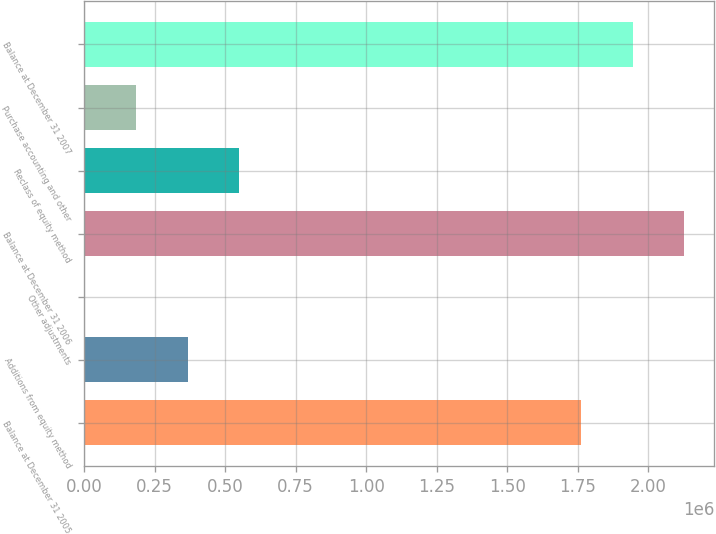Convert chart to OTSL. <chart><loc_0><loc_0><loc_500><loc_500><bar_chart><fcel>Balance at December 31 2005<fcel>Additions from equity method<fcel>Other adjustments<fcel>Balance at December 31 2006<fcel>Reclass of equity method<fcel>Purchase accounting and other<fcel>Balance at December 31 2007<nl><fcel>1.76185e+06<fcel>366817<fcel>1500<fcel>2.12716e+06<fcel>549476<fcel>184158<fcel>1.94451e+06<nl></chart> 